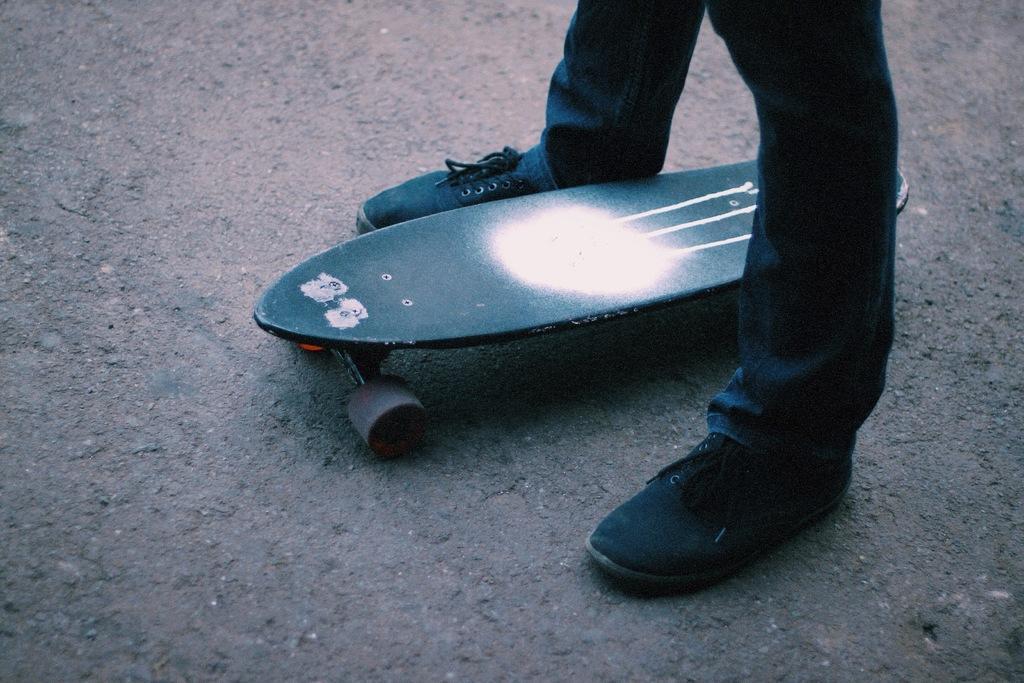Please provide a concise description of this image. A person is standing, she wore trouser, shoes. In the middle there is a skateboard. 